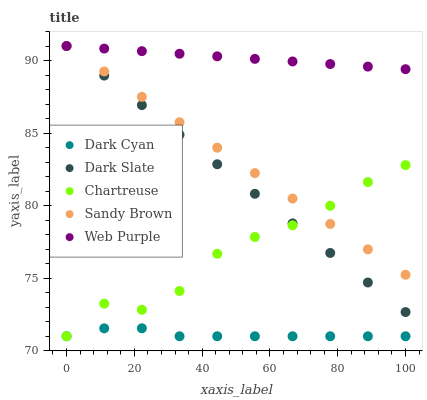Does Dark Cyan have the minimum area under the curve?
Answer yes or no. Yes. Does Web Purple have the maximum area under the curve?
Answer yes or no. Yes. Does Dark Slate have the minimum area under the curve?
Answer yes or no. No. Does Dark Slate have the maximum area under the curve?
Answer yes or no. No. Is Web Purple the smoothest?
Answer yes or no. Yes. Is Chartreuse the roughest?
Answer yes or no. Yes. Is Dark Slate the smoothest?
Answer yes or no. No. Is Dark Slate the roughest?
Answer yes or no. No. Does Dark Cyan have the lowest value?
Answer yes or no. Yes. Does Dark Slate have the lowest value?
Answer yes or no. No. Does Web Purple have the highest value?
Answer yes or no. Yes. Does Chartreuse have the highest value?
Answer yes or no. No. Is Dark Cyan less than Web Purple?
Answer yes or no. Yes. Is Dark Slate greater than Dark Cyan?
Answer yes or no. Yes. Does Chartreuse intersect Dark Cyan?
Answer yes or no. Yes. Is Chartreuse less than Dark Cyan?
Answer yes or no. No. Is Chartreuse greater than Dark Cyan?
Answer yes or no. No. Does Dark Cyan intersect Web Purple?
Answer yes or no. No. 